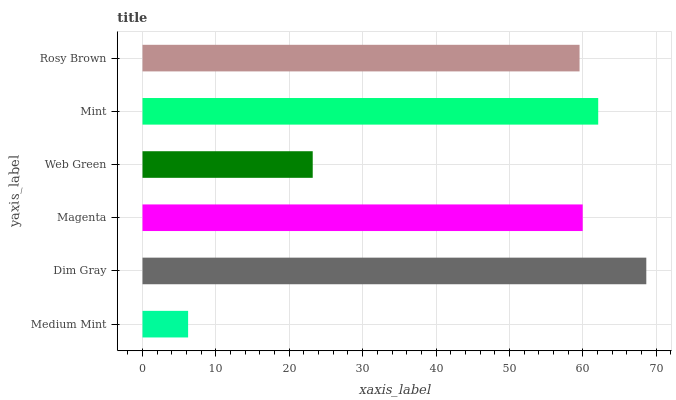Is Medium Mint the minimum?
Answer yes or no. Yes. Is Dim Gray the maximum?
Answer yes or no. Yes. Is Magenta the minimum?
Answer yes or no. No. Is Magenta the maximum?
Answer yes or no. No. Is Dim Gray greater than Magenta?
Answer yes or no. Yes. Is Magenta less than Dim Gray?
Answer yes or no. Yes. Is Magenta greater than Dim Gray?
Answer yes or no. No. Is Dim Gray less than Magenta?
Answer yes or no. No. Is Magenta the high median?
Answer yes or no. Yes. Is Rosy Brown the low median?
Answer yes or no. Yes. Is Web Green the high median?
Answer yes or no. No. Is Dim Gray the low median?
Answer yes or no. No. 